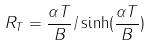<formula> <loc_0><loc_0><loc_500><loc_500>R _ { T } = \frac { \alpha T } { B } / \sinh ( \frac { \alpha T } { B } )</formula> 